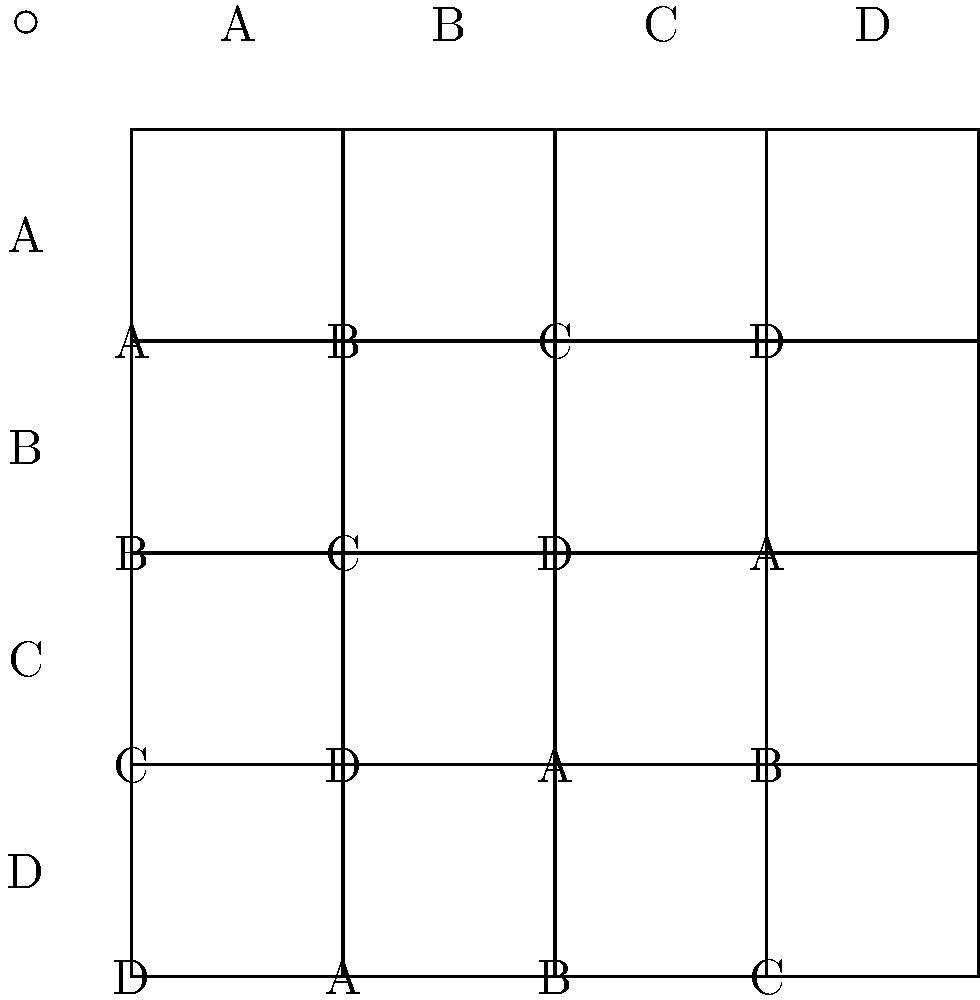In a high-stakes corporate lawsuit, you're analyzing the composition of legal teams using group theory. The Cayley table above represents the operation of combining two lawyers (A, B, C, D) to form a new team. If you have lawyers A and C, and need to add a third lawyer to maximize the team's effectiveness, which lawyer should you choose to ensure the resulting team is equivalent to team B? To solve this problem, we need to follow these steps:

1. Understand the given information:
   - We have lawyers A and C
   - We need to find a lawyer X such that A $\circ$ C $\circ$ X = B

2. Use the Cayley table to find A $\circ$ C:
   - Look at row A and column C
   - A $\circ$ C = D

3. Now we need to find X such that D $\circ$ X = B:
   - Look at row D in the Cayley table
   - We need to find the column where D $\circ$ X results in B
   - This occurs in column C

4. Therefore, the lawyer X we need to add is C

By choosing lawyer C, we ensure that (A $\circ$ C) $\circ$ C = D $\circ$ C = B, which meets our requirement of forming team B.
Answer: Lawyer C 